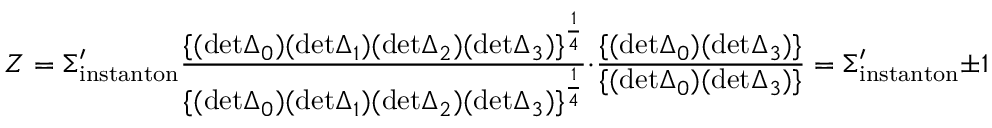<formula> <loc_0><loc_0><loc_500><loc_500>Z = \Sigma _ { i n s t a n t o n } ^ { \prime } { \frac { \{ ( d e t \Delta _ { 0 } ) ( d e t \Delta _ { 1 } ) ( d e t \Delta _ { 2 } ) ( d e t \Delta _ { 3 } ) \} ^ { \frac { 1 } { 4 } } } { \{ ( d e t \Delta _ { 0 } ) ( d e t \Delta _ { 1 } ) ( d e t \Delta _ { 2 } ) ( d e t \Delta _ { 3 } ) \} ^ { \frac { 1 } { 4 } } } } \cdot { \frac { \{ ( d e t \Delta _ { 0 } ) ( d e t \Delta _ { 3 } ) \} } { \{ ( d e t \Delta _ { 0 } ) ( d e t \Delta _ { 3 } ) \} } } = \Sigma _ { i n s t a n t o n } ^ { \prime } \pm 1</formula> 